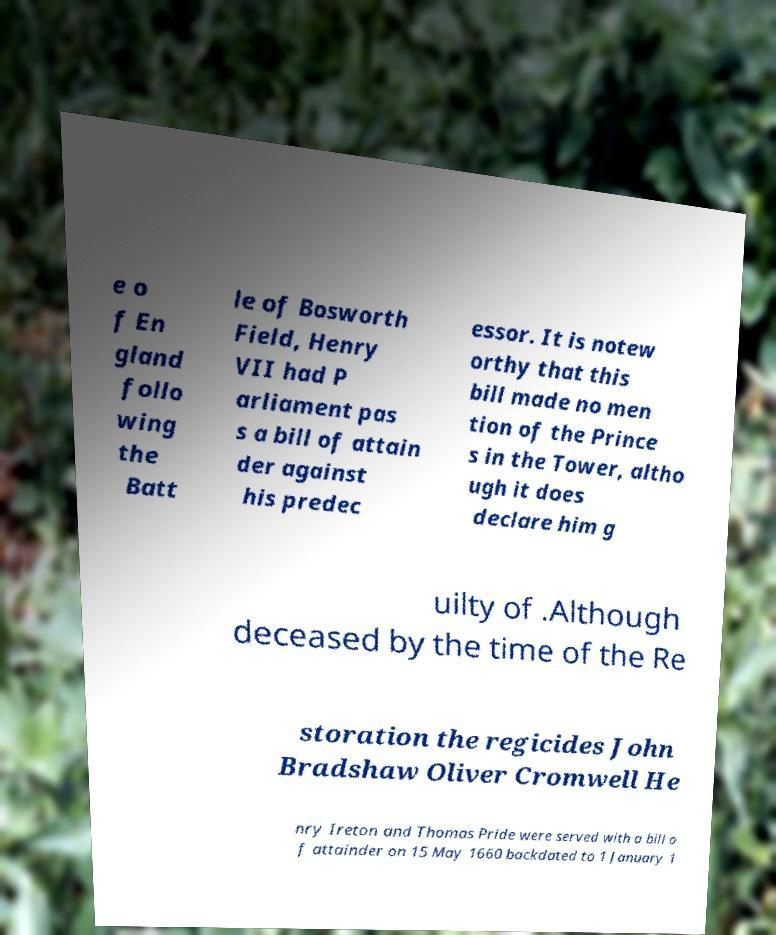Could you extract and type out the text from this image? e o f En gland follo wing the Batt le of Bosworth Field, Henry VII had P arliament pas s a bill of attain der against his predec essor. It is notew orthy that this bill made no men tion of the Prince s in the Tower, altho ugh it does declare him g uilty of .Although deceased by the time of the Re storation the regicides John Bradshaw Oliver Cromwell He nry Ireton and Thomas Pride were served with a bill o f attainder on 15 May 1660 backdated to 1 January 1 